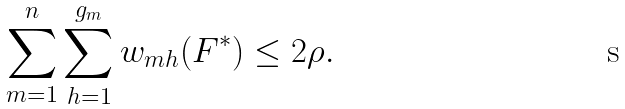Convert formula to latex. <formula><loc_0><loc_0><loc_500><loc_500>\sum _ { m = 1 } ^ { n } \sum _ { h = 1 } ^ { g _ { m } } w _ { m h } ( F ^ { * } ) \leq 2 \rho .</formula> 